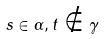Convert formula to latex. <formula><loc_0><loc_0><loc_500><loc_500>s \in \alpha , t \notin \gamma</formula> 